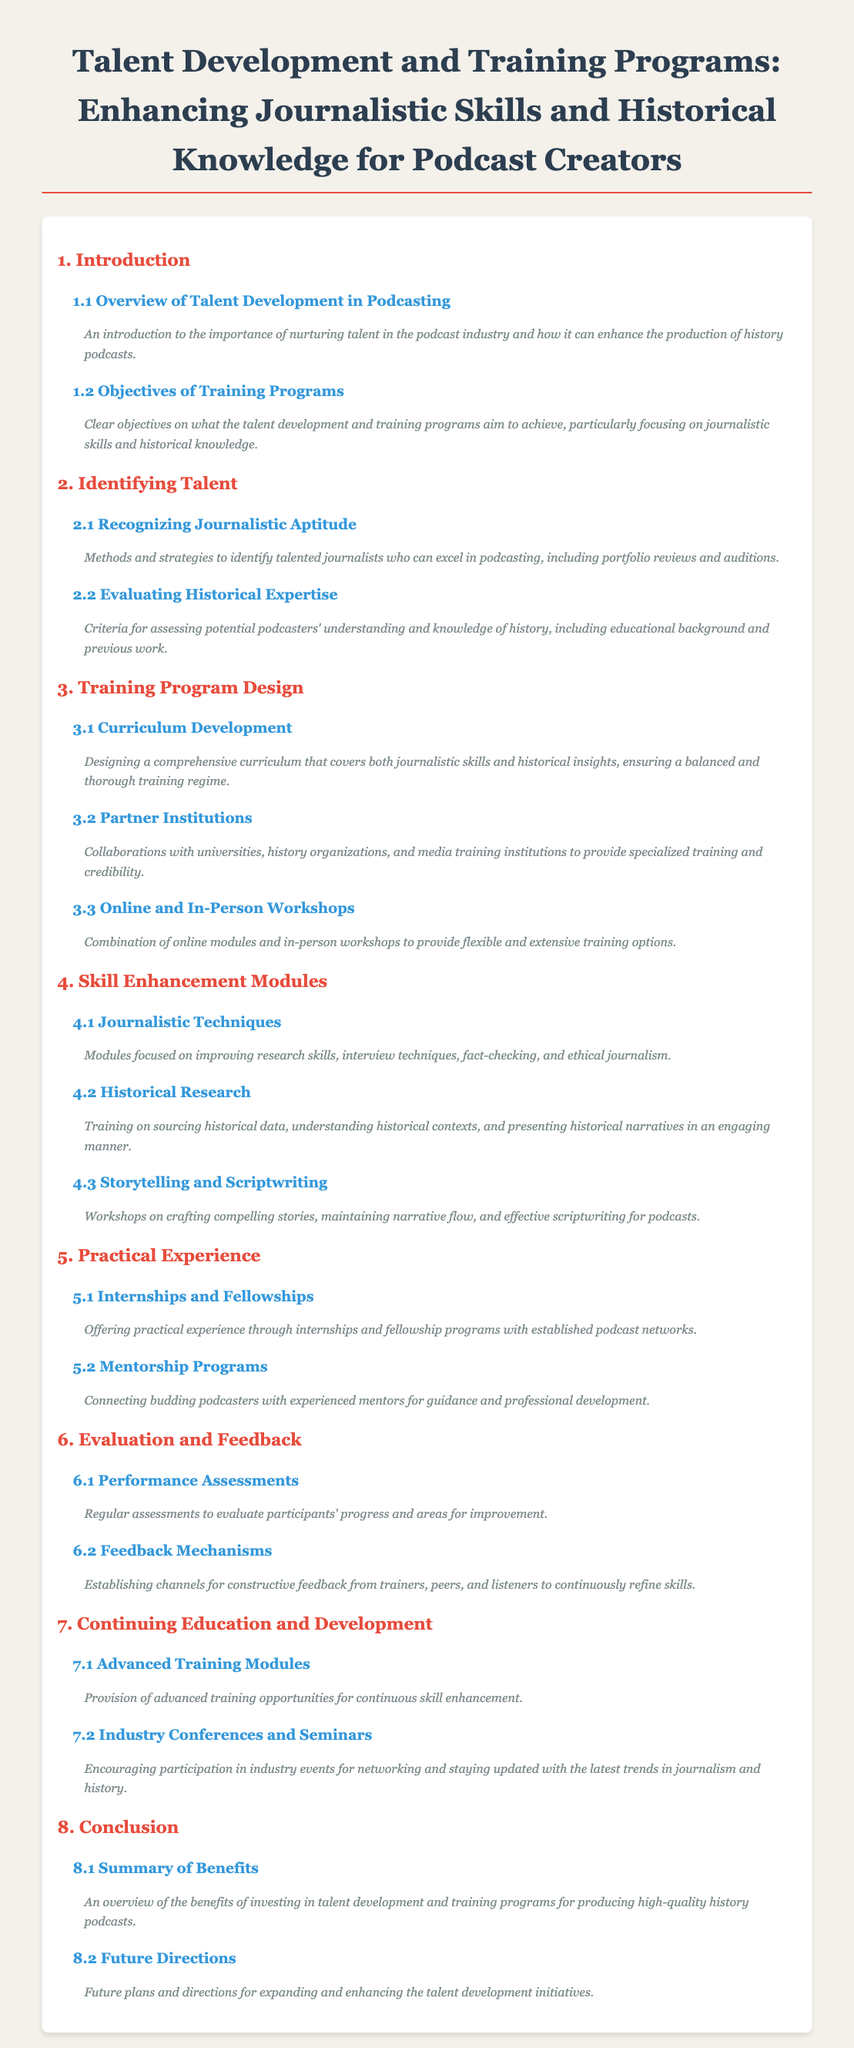What is the title of the document? The title of the document is provided in the heading at the top of the table of contents.
Answer: Talent Development and Training Programs: Enhancing Journalistic Skills and Historical Knowledge for Podcast Creators What is discussed in section 1.1? Section 1.1 gives an overview of the importance of nurturing talent in the podcast industry.
Answer: Overview of Talent Development in Podcasting Which section covers practical experience opportunities? The section that discusses practical experience is identified by its number in the table of contents.
Answer: Section 5 How many subsections are there in section 3? The number of subsections in section 3 can be counted from the list presented in the document.
Answer: Three What is the focus of the 4.1 module? The focus of the 4.1 module is detailed in its title, providing insight into its content.
Answer: Journalistic Techniques What type of feedback is mentioned in section 6.2? Section 6.2 mentions the establishment of specific channels for a certain kind of feedback.
Answer: Feedback Mechanisms What is the purpose of internships according to section 5.1? The purpose of internships is described succinctly in the subsection.
Answer: Offering practical experience What does section 8.1 summarize? Section 8.1 provides a summary regarding certain outcomes discussed earlier in the document.
Answer: Summary of Benefits 